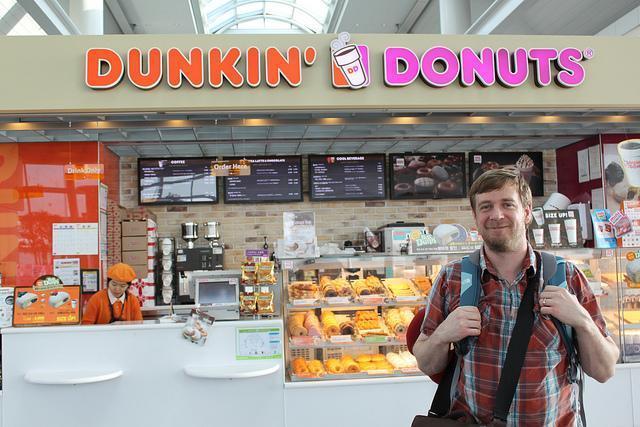How many people are in this photo?
Give a very brief answer. 2. How many people are behind the counter, working?
Give a very brief answer. 1. How many people are there?
Give a very brief answer. 2. How many bird legs are visible?
Give a very brief answer. 0. 